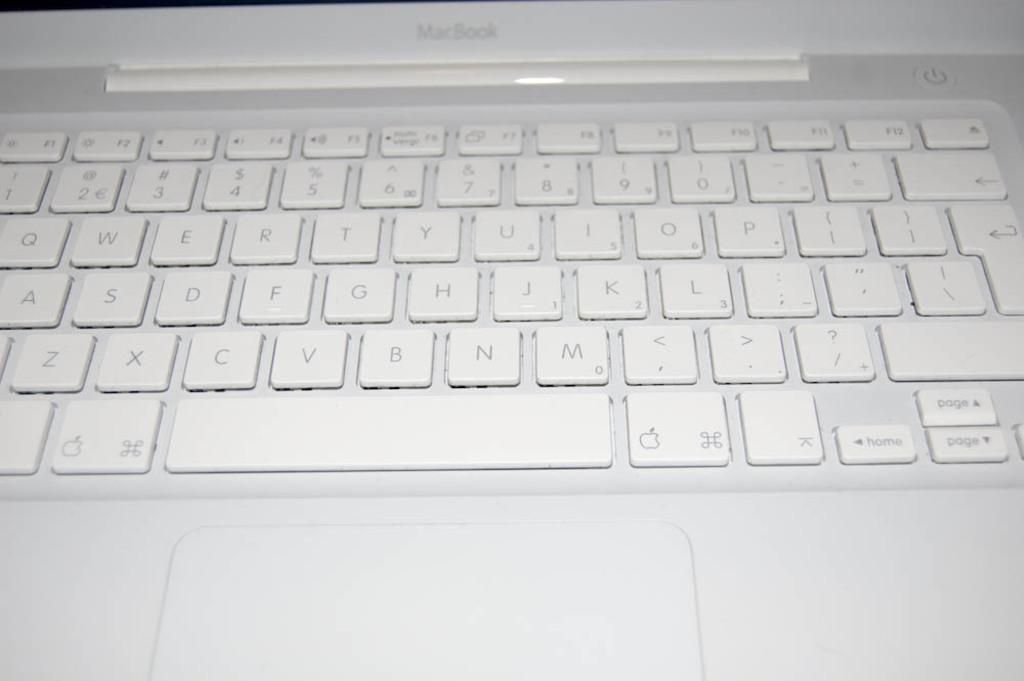What type of computer is visible in the image? There is a MacBook in the image. What is located at the bottom of the image? There is a keyboard at the bottom of the image. What device is used for input in the image? There is a mouse in the image. What color are the keys on the keyboard? The keys on the keyboard are in white color. What type of vegetable is being used as a mousepad in the image? There is no vegetable present in the image, and the mouse is not using a vegetable as a mousepad. 